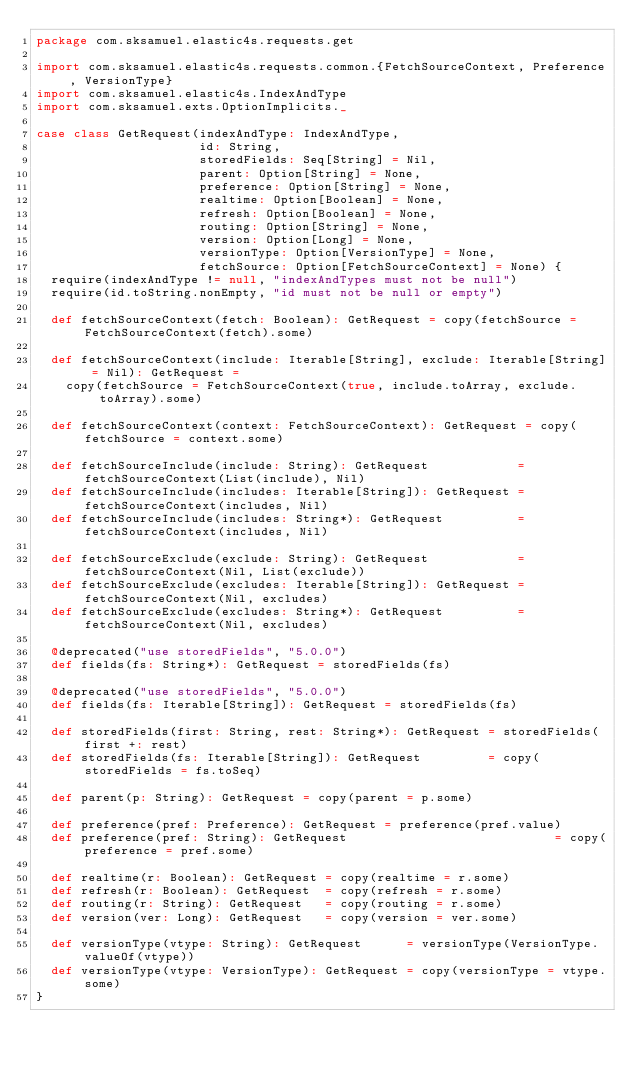Convert code to text. <code><loc_0><loc_0><loc_500><loc_500><_Scala_>package com.sksamuel.elastic4s.requests.get

import com.sksamuel.elastic4s.requests.common.{FetchSourceContext, Preference, VersionType}
import com.sksamuel.elastic4s.IndexAndType
import com.sksamuel.exts.OptionImplicits._

case class GetRequest(indexAndType: IndexAndType,
                      id: String,
                      storedFields: Seq[String] = Nil,
                      parent: Option[String] = None,
                      preference: Option[String] = None,
                      realtime: Option[Boolean] = None,
                      refresh: Option[Boolean] = None,
                      routing: Option[String] = None,
                      version: Option[Long] = None,
                      versionType: Option[VersionType] = None,
                      fetchSource: Option[FetchSourceContext] = None) {
  require(indexAndType != null, "indexAndTypes must not be null")
  require(id.toString.nonEmpty, "id must not be null or empty")

  def fetchSourceContext(fetch: Boolean): GetRequest = copy(fetchSource = FetchSourceContext(fetch).some)

  def fetchSourceContext(include: Iterable[String], exclude: Iterable[String] = Nil): GetRequest =
    copy(fetchSource = FetchSourceContext(true, include.toArray, exclude.toArray).some)

  def fetchSourceContext(context: FetchSourceContext): GetRequest = copy(fetchSource = context.some)

  def fetchSourceInclude(include: String): GetRequest            = fetchSourceContext(List(include), Nil)
  def fetchSourceInclude(includes: Iterable[String]): GetRequest = fetchSourceContext(includes, Nil)
  def fetchSourceInclude(includes: String*): GetRequest          = fetchSourceContext(includes, Nil)

  def fetchSourceExclude(exclude: String): GetRequest            = fetchSourceContext(Nil, List(exclude))
  def fetchSourceExclude(excludes: Iterable[String]): GetRequest = fetchSourceContext(Nil, excludes)
  def fetchSourceExclude(excludes: String*): GetRequest          = fetchSourceContext(Nil, excludes)

  @deprecated("use storedFields", "5.0.0")
  def fields(fs: String*): GetRequest = storedFields(fs)

  @deprecated("use storedFields", "5.0.0")
  def fields(fs: Iterable[String]): GetRequest = storedFields(fs)

  def storedFields(first: String, rest: String*): GetRequest = storedFields(first +: rest)
  def storedFields(fs: Iterable[String]): GetRequest         = copy(storedFields = fs.toSeq)

  def parent(p: String): GetRequest = copy(parent = p.some)

  def preference(pref: Preference): GetRequest = preference(pref.value)
  def preference(pref: String): GetRequest                            = copy(preference = pref.some)

  def realtime(r: Boolean): GetRequest = copy(realtime = r.some)
  def refresh(r: Boolean): GetRequest  = copy(refresh = r.some)
  def routing(r: String): GetRequest   = copy(routing = r.some)
  def version(ver: Long): GetRequest   = copy(version = ver.some)

  def versionType(vtype: String): GetRequest      = versionType(VersionType.valueOf(vtype))
  def versionType(vtype: VersionType): GetRequest = copy(versionType = vtype.some)
}
</code> 